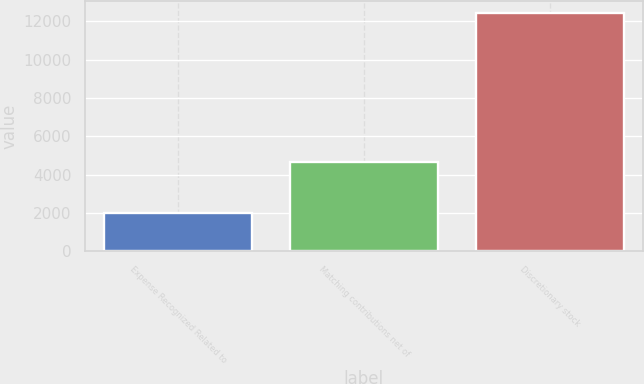<chart> <loc_0><loc_0><loc_500><loc_500><bar_chart><fcel>Expense Recognized Related to<fcel>Matching contributions net of<fcel>Discretionary stock<nl><fcel>2008<fcel>4641<fcel>12436<nl></chart> 